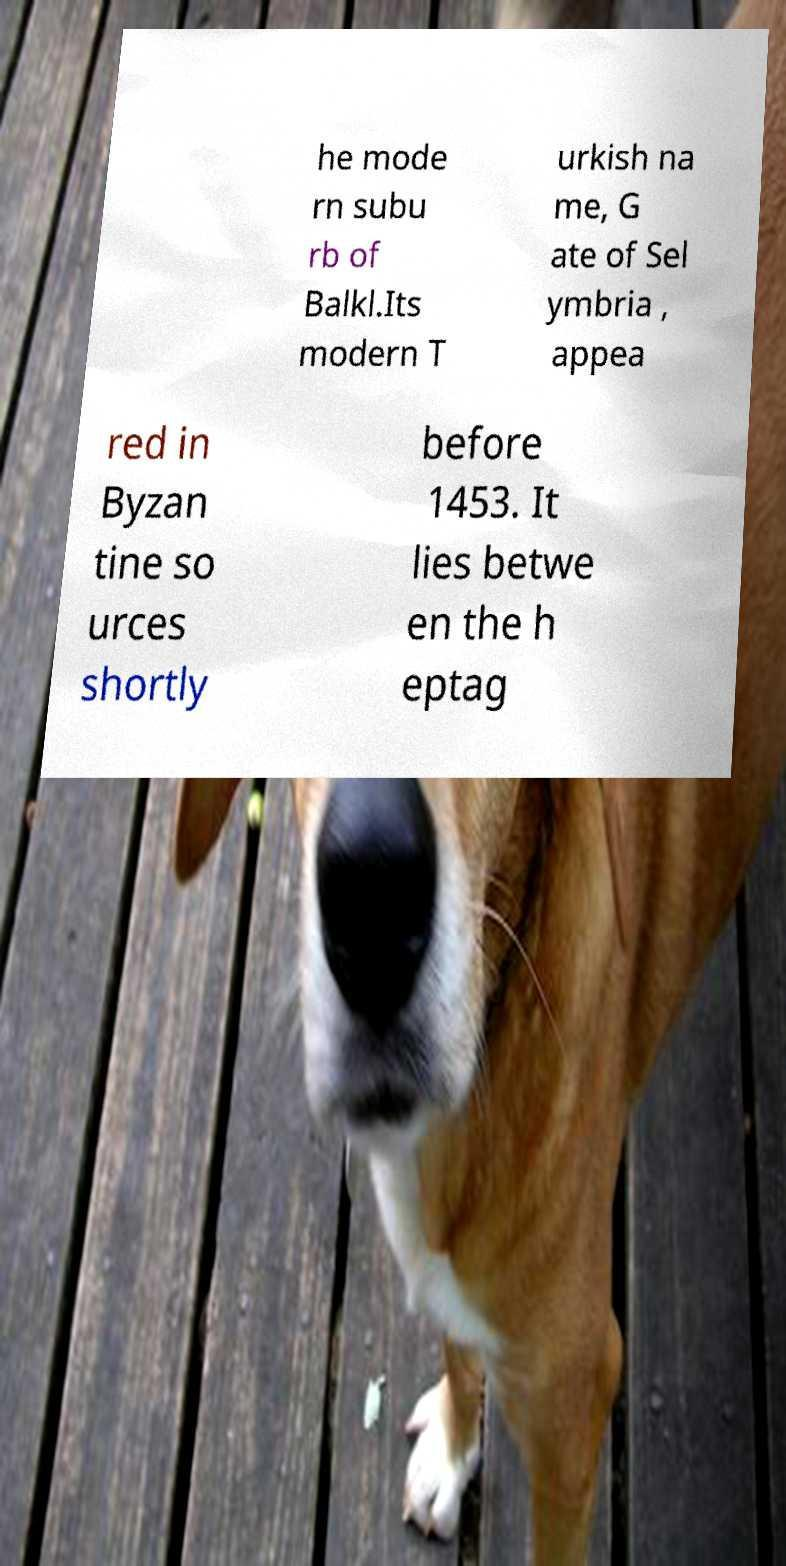Can you accurately transcribe the text from the provided image for me? he mode rn subu rb of Balkl.Its modern T urkish na me, G ate of Sel ymbria , appea red in Byzan tine so urces shortly before 1453. It lies betwe en the h eptag 